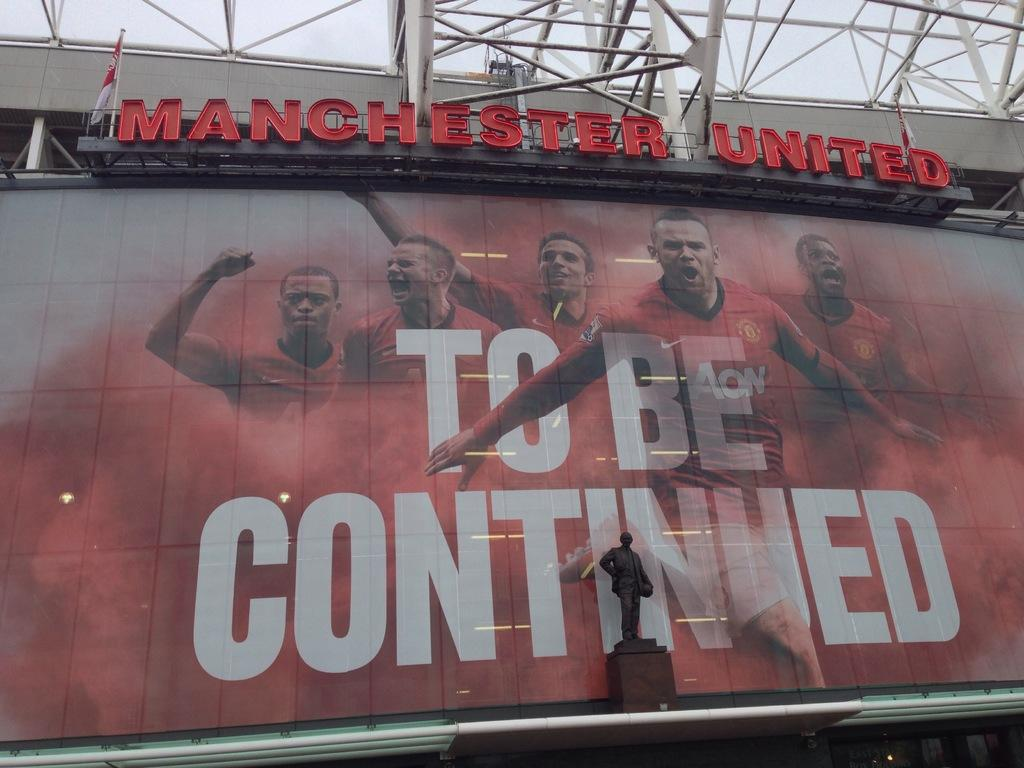<image>
Render a clear and concise summary of the photo. Signboard for Manchester United with the words TO BE CONTINUED displayed. 